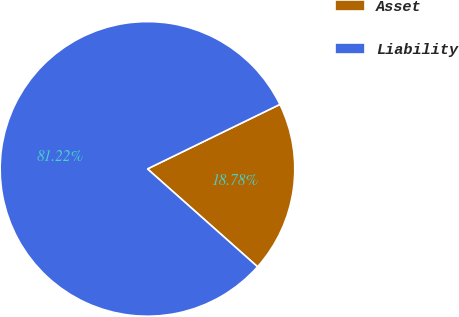Convert chart to OTSL. <chart><loc_0><loc_0><loc_500><loc_500><pie_chart><fcel>Asset<fcel>Liability<nl><fcel>18.78%<fcel>81.22%<nl></chart> 